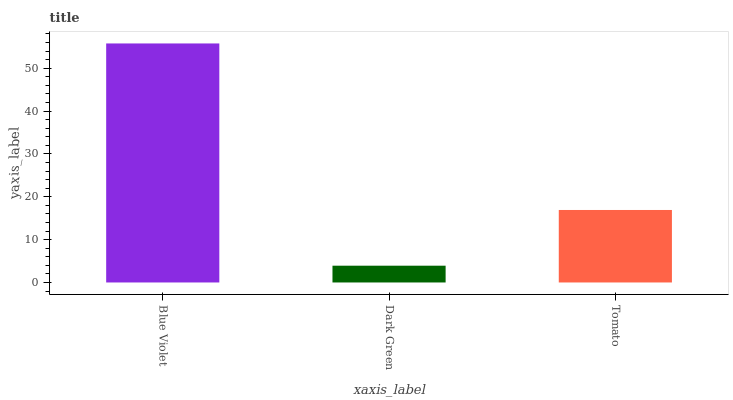Is Dark Green the minimum?
Answer yes or no. Yes. Is Blue Violet the maximum?
Answer yes or no. Yes. Is Tomato the minimum?
Answer yes or no. No. Is Tomato the maximum?
Answer yes or no. No. Is Tomato greater than Dark Green?
Answer yes or no. Yes. Is Dark Green less than Tomato?
Answer yes or no. Yes. Is Dark Green greater than Tomato?
Answer yes or no. No. Is Tomato less than Dark Green?
Answer yes or no. No. Is Tomato the high median?
Answer yes or no. Yes. Is Tomato the low median?
Answer yes or no. Yes. Is Blue Violet the high median?
Answer yes or no. No. Is Blue Violet the low median?
Answer yes or no. No. 